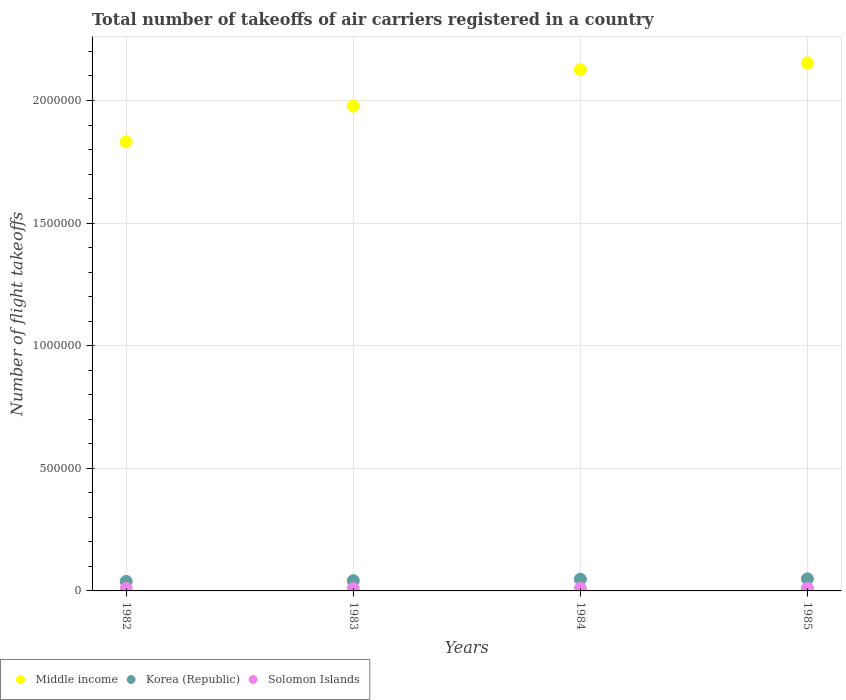How many different coloured dotlines are there?
Your answer should be very brief. 3. Is the number of dotlines equal to the number of legend labels?
Make the answer very short. Yes. What is the total number of flight takeoffs in Korea (Republic) in 1982?
Ensure brevity in your answer.  3.89e+04. Across all years, what is the maximum total number of flight takeoffs in Solomon Islands?
Offer a terse response. 1.09e+04. Across all years, what is the minimum total number of flight takeoffs in Korea (Republic)?
Provide a succinct answer. 3.89e+04. In which year was the total number of flight takeoffs in Korea (Republic) maximum?
Provide a succinct answer. 1985. In which year was the total number of flight takeoffs in Solomon Islands minimum?
Offer a terse response. 1983. What is the total total number of flight takeoffs in Solomon Islands in the graph?
Offer a very short reply. 4.12e+04. What is the difference between the total number of flight takeoffs in Korea (Republic) in 1984 and that in 1985?
Your response must be concise. -1200. What is the difference between the total number of flight takeoffs in Solomon Islands in 1984 and the total number of flight takeoffs in Korea (Republic) in 1982?
Ensure brevity in your answer.  -2.82e+04. What is the average total number of flight takeoffs in Middle income per year?
Give a very brief answer. 2.02e+06. In the year 1984, what is the difference between the total number of flight takeoffs in Solomon Islands and total number of flight takeoffs in Korea (Republic)?
Ensure brevity in your answer.  -3.72e+04. In how many years, is the total number of flight takeoffs in Korea (Republic) greater than 600000?
Your answer should be very brief. 0. What is the ratio of the total number of flight takeoffs in Middle income in 1982 to that in 1983?
Provide a succinct answer. 0.93. Is the total number of flight takeoffs in Solomon Islands in 1983 less than that in 1985?
Ensure brevity in your answer.  Yes. What is the difference between the highest and the second highest total number of flight takeoffs in Korea (Republic)?
Your response must be concise. 1200. What is the difference between the highest and the lowest total number of flight takeoffs in Middle income?
Ensure brevity in your answer.  3.22e+05. In how many years, is the total number of flight takeoffs in Middle income greater than the average total number of flight takeoffs in Middle income taken over all years?
Keep it short and to the point. 2. Is the sum of the total number of flight takeoffs in Solomon Islands in 1982 and 1983 greater than the maximum total number of flight takeoffs in Korea (Republic) across all years?
Keep it short and to the point. No. Is the total number of flight takeoffs in Middle income strictly greater than the total number of flight takeoffs in Korea (Republic) over the years?
Provide a short and direct response. Yes. Is the total number of flight takeoffs in Korea (Republic) strictly less than the total number of flight takeoffs in Middle income over the years?
Your answer should be compact. Yes. How many dotlines are there?
Give a very brief answer. 3. How many years are there in the graph?
Provide a succinct answer. 4. Are the values on the major ticks of Y-axis written in scientific E-notation?
Give a very brief answer. No. What is the title of the graph?
Keep it short and to the point. Total number of takeoffs of air carriers registered in a country. What is the label or title of the X-axis?
Provide a short and direct response. Years. What is the label or title of the Y-axis?
Keep it short and to the point. Number of flight takeoffs. What is the Number of flight takeoffs of Middle income in 1982?
Keep it short and to the point. 1.83e+06. What is the Number of flight takeoffs in Korea (Republic) in 1982?
Your answer should be very brief. 3.89e+04. What is the Number of flight takeoffs in Middle income in 1983?
Your answer should be compact. 1.98e+06. What is the Number of flight takeoffs in Korea (Republic) in 1983?
Your answer should be compact. 4.17e+04. What is the Number of flight takeoffs in Solomon Islands in 1983?
Offer a very short reply. 9600. What is the Number of flight takeoffs of Middle income in 1984?
Ensure brevity in your answer.  2.13e+06. What is the Number of flight takeoffs of Korea (Republic) in 1984?
Your answer should be compact. 4.79e+04. What is the Number of flight takeoffs in Solomon Islands in 1984?
Provide a succinct answer. 1.07e+04. What is the Number of flight takeoffs in Middle income in 1985?
Your response must be concise. 2.15e+06. What is the Number of flight takeoffs of Korea (Republic) in 1985?
Give a very brief answer. 4.91e+04. What is the Number of flight takeoffs of Solomon Islands in 1985?
Keep it short and to the point. 1.09e+04. Across all years, what is the maximum Number of flight takeoffs of Middle income?
Give a very brief answer. 2.15e+06. Across all years, what is the maximum Number of flight takeoffs of Korea (Republic)?
Provide a succinct answer. 4.91e+04. Across all years, what is the maximum Number of flight takeoffs of Solomon Islands?
Provide a short and direct response. 1.09e+04. Across all years, what is the minimum Number of flight takeoffs in Middle income?
Give a very brief answer. 1.83e+06. Across all years, what is the minimum Number of flight takeoffs of Korea (Republic)?
Your response must be concise. 3.89e+04. Across all years, what is the minimum Number of flight takeoffs in Solomon Islands?
Give a very brief answer. 9600. What is the total Number of flight takeoffs of Middle income in the graph?
Your response must be concise. 8.09e+06. What is the total Number of flight takeoffs in Korea (Republic) in the graph?
Keep it short and to the point. 1.78e+05. What is the total Number of flight takeoffs in Solomon Islands in the graph?
Your response must be concise. 4.12e+04. What is the difference between the Number of flight takeoffs in Middle income in 1982 and that in 1983?
Provide a succinct answer. -1.46e+05. What is the difference between the Number of flight takeoffs of Korea (Republic) in 1982 and that in 1983?
Ensure brevity in your answer.  -2800. What is the difference between the Number of flight takeoffs in Middle income in 1982 and that in 1984?
Keep it short and to the point. -2.94e+05. What is the difference between the Number of flight takeoffs of Korea (Republic) in 1982 and that in 1984?
Your answer should be compact. -9000. What is the difference between the Number of flight takeoffs in Solomon Islands in 1982 and that in 1984?
Your answer should be very brief. -700. What is the difference between the Number of flight takeoffs in Middle income in 1982 and that in 1985?
Give a very brief answer. -3.22e+05. What is the difference between the Number of flight takeoffs of Korea (Republic) in 1982 and that in 1985?
Make the answer very short. -1.02e+04. What is the difference between the Number of flight takeoffs of Solomon Islands in 1982 and that in 1985?
Offer a terse response. -900. What is the difference between the Number of flight takeoffs of Middle income in 1983 and that in 1984?
Keep it short and to the point. -1.49e+05. What is the difference between the Number of flight takeoffs of Korea (Republic) in 1983 and that in 1984?
Provide a short and direct response. -6200. What is the difference between the Number of flight takeoffs in Solomon Islands in 1983 and that in 1984?
Keep it short and to the point. -1100. What is the difference between the Number of flight takeoffs in Middle income in 1983 and that in 1985?
Your answer should be very brief. -1.76e+05. What is the difference between the Number of flight takeoffs in Korea (Republic) in 1983 and that in 1985?
Your answer should be compact. -7400. What is the difference between the Number of flight takeoffs of Solomon Islands in 1983 and that in 1985?
Provide a succinct answer. -1300. What is the difference between the Number of flight takeoffs of Middle income in 1984 and that in 1985?
Give a very brief answer. -2.78e+04. What is the difference between the Number of flight takeoffs of Korea (Republic) in 1984 and that in 1985?
Ensure brevity in your answer.  -1200. What is the difference between the Number of flight takeoffs of Solomon Islands in 1984 and that in 1985?
Provide a succinct answer. -200. What is the difference between the Number of flight takeoffs in Middle income in 1982 and the Number of flight takeoffs in Korea (Republic) in 1983?
Your answer should be very brief. 1.79e+06. What is the difference between the Number of flight takeoffs in Middle income in 1982 and the Number of flight takeoffs in Solomon Islands in 1983?
Give a very brief answer. 1.82e+06. What is the difference between the Number of flight takeoffs in Korea (Republic) in 1982 and the Number of flight takeoffs in Solomon Islands in 1983?
Make the answer very short. 2.93e+04. What is the difference between the Number of flight takeoffs of Middle income in 1982 and the Number of flight takeoffs of Korea (Republic) in 1984?
Offer a terse response. 1.78e+06. What is the difference between the Number of flight takeoffs in Middle income in 1982 and the Number of flight takeoffs in Solomon Islands in 1984?
Your answer should be compact. 1.82e+06. What is the difference between the Number of flight takeoffs in Korea (Republic) in 1982 and the Number of flight takeoffs in Solomon Islands in 1984?
Make the answer very short. 2.82e+04. What is the difference between the Number of flight takeoffs of Middle income in 1982 and the Number of flight takeoffs of Korea (Republic) in 1985?
Offer a terse response. 1.78e+06. What is the difference between the Number of flight takeoffs in Middle income in 1982 and the Number of flight takeoffs in Solomon Islands in 1985?
Ensure brevity in your answer.  1.82e+06. What is the difference between the Number of flight takeoffs in Korea (Republic) in 1982 and the Number of flight takeoffs in Solomon Islands in 1985?
Keep it short and to the point. 2.80e+04. What is the difference between the Number of flight takeoffs of Middle income in 1983 and the Number of flight takeoffs of Korea (Republic) in 1984?
Your answer should be very brief. 1.93e+06. What is the difference between the Number of flight takeoffs of Middle income in 1983 and the Number of flight takeoffs of Solomon Islands in 1984?
Your response must be concise. 1.97e+06. What is the difference between the Number of flight takeoffs in Korea (Republic) in 1983 and the Number of flight takeoffs in Solomon Islands in 1984?
Offer a very short reply. 3.10e+04. What is the difference between the Number of flight takeoffs of Middle income in 1983 and the Number of flight takeoffs of Korea (Republic) in 1985?
Keep it short and to the point. 1.93e+06. What is the difference between the Number of flight takeoffs in Middle income in 1983 and the Number of flight takeoffs in Solomon Islands in 1985?
Your answer should be compact. 1.97e+06. What is the difference between the Number of flight takeoffs in Korea (Republic) in 1983 and the Number of flight takeoffs in Solomon Islands in 1985?
Make the answer very short. 3.08e+04. What is the difference between the Number of flight takeoffs in Middle income in 1984 and the Number of flight takeoffs in Korea (Republic) in 1985?
Your answer should be very brief. 2.08e+06. What is the difference between the Number of flight takeoffs in Middle income in 1984 and the Number of flight takeoffs in Solomon Islands in 1985?
Ensure brevity in your answer.  2.11e+06. What is the difference between the Number of flight takeoffs in Korea (Republic) in 1984 and the Number of flight takeoffs in Solomon Islands in 1985?
Keep it short and to the point. 3.70e+04. What is the average Number of flight takeoffs of Middle income per year?
Offer a terse response. 2.02e+06. What is the average Number of flight takeoffs of Korea (Republic) per year?
Provide a short and direct response. 4.44e+04. What is the average Number of flight takeoffs in Solomon Islands per year?
Give a very brief answer. 1.03e+04. In the year 1982, what is the difference between the Number of flight takeoffs in Middle income and Number of flight takeoffs in Korea (Republic)?
Ensure brevity in your answer.  1.79e+06. In the year 1982, what is the difference between the Number of flight takeoffs of Middle income and Number of flight takeoffs of Solomon Islands?
Make the answer very short. 1.82e+06. In the year 1982, what is the difference between the Number of flight takeoffs of Korea (Republic) and Number of flight takeoffs of Solomon Islands?
Ensure brevity in your answer.  2.89e+04. In the year 1983, what is the difference between the Number of flight takeoffs of Middle income and Number of flight takeoffs of Korea (Republic)?
Provide a succinct answer. 1.94e+06. In the year 1983, what is the difference between the Number of flight takeoffs in Middle income and Number of flight takeoffs in Solomon Islands?
Keep it short and to the point. 1.97e+06. In the year 1983, what is the difference between the Number of flight takeoffs of Korea (Republic) and Number of flight takeoffs of Solomon Islands?
Give a very brief answer. 3.21e+04. In the year 1984, what is the difference between the Number of flight takeoffs of Middle income and Number of flight takeoffs of Korea (Republic)?
Ensure brevity in your answer.  2.08e+06. In the year 1984, what is the difference between the Number of flight takeoffs in Middle income and Number of flight takeoffs in Solomon Islands?
Offer a terse response. 2.12e+06. In the year 1984, what is the difference between the Number of flight takeoffs in Korea (Republic) and Number of flight takeoffs in Solomon Islands?
Give a very brief answer. 3.72e+04. In the year 1985, what is the difference between the Number of flight takeoffs in Middle income and Number of flight takeoffs in Korea (Republic)?
Offer a terse response. 2.10e+06. In the year 1985, what is the difference between the Number of flight takeoffs in Middle income and Number of flight takeoffs in Solomon Islands?
Offer a very short reply. 2.14e+06. In the year 1985, what is the difference between the Number of flight takeoffs in Korea (Republic) and Number of flight takeoffs in Solomon Islands?
Provide a succinct answer. 3.82e+04. What is the ratio of the Number of flight takeoffs in Middle income in 1982 to that in 1983?
Your response must be concise. 0.93. What is the ratio of the Number of flight takeoffs in Korea (Republic) in 1982 to that in 1983?
Your answer should be compact. 0.93. What is the ratio of the Number of flight takeoffs in Solomon Islands in 1982 to that in 1983?
Make the answer very short. 1.04. What is the ratio of the Number of flight takeoffs of Middle income in 1982 to that in 1984?
Make the answer very short. 0.86. What is the ratio of the Number of flight takeoffs in Korea (Republic) in 1982 to that in 1984?
Your answer should be compact. 0.81. What is the ratio of the Number of flight takeoffs in Solomon Islands in 1982 to that in 1984?
Offer a terse response. 0.93. What is the ratio of the Number of flight takeoffs of Middle income in 1982 to that in 1985?
Your response must be concise. 0.85. What is the ratio of the Number of flight takeoffs in Korea (Republic) in 1982 to that in 1985?
Offer a terse response. 0.79. What is the ratio of the Number of flight takeoffs of Solomon Islands in 1982 to that in 1985?
Provide a short and direct response. 0.92. What is the ratio of the Number of flight takeoffs in Middle income in 1983 to that in 1984?
Your answer should be very brief. 0.93. What is the ratio of the Number of flight takeoffs of Korea (Republic) in 1983 to that in 1984?
Ensure brevity in your answer.  0.87. What is the ratio of the Number of flight takeoffs in Solomon Islands in 1983 to that in 1984?
Provide a succinct answer. 0.9. What is the ratio of the Number of flight takeoffs of Middle income in 1983 to that in 1985?
Give a very brief answer. 0.92. What is the ratio of the Number of flight takeoffs of Korea (Republic) in 1983 to that in 1985?
Ensure brevity in your answer.  0.85. What is the ratio of the Number of flight takeoffs of Solomon Islands in 1983 to that in 1985?
Make the answer very short. 0.88. What is the ratio of the Number of flight takeoffs of Middle income in 1984 to that in 1985?
Ensure brevity in your answer.  0.99. What is the ratio of the Number of flight takeoffs of Korea (Republic) in 1984 to that in 1985?
Ensure brevity in your answer.  0.98. What is the ratio of the Number of flight takeoffs in Solomon Islands in 1984 to that in 1985?
Make the answer very short. 0.98. What is the difference between the highest and the second highest Number of flight takeoffs in Middle income?
Ensure brevity in your answer.  2.78e+04. What is the difference between the highest and the second highest Number of flight takeoffs in Korea (Republic)?
Keep it short and to the point. 1200. What is the difference between the highest and the second highest Number of flight takeoffs in Solomon Islands?
Provide a short and direct response. 200. What is the difference between the highest and the lowest Number of flight takeoffs of Middle income?
Keep it short and to the point. 3.22e+05. What is the difference between the highest and the lowest Number of flight takeoffs of Korea (Republic)?
Offer a terse response. 1.02e+04. What is the difference between the highest and the lowest Number of flight takeoffs of Solomon Islands?
Give a very brief answer. 1300. 